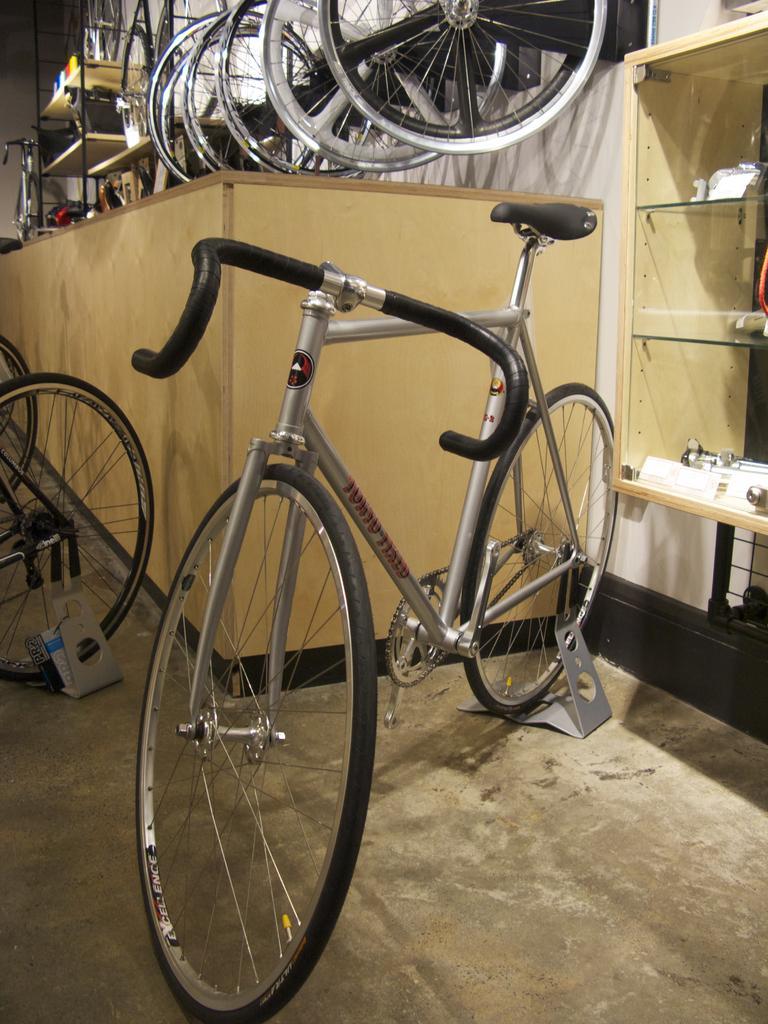Could you give a brief overview of what you see in this image? In front of the picture, we see the bicycle. Behind that, we see a table on which the bicycles are placed. On the right side, we see a rack. In the background, we see the bicycles and a rack. This picture might be clicked in the bicycle garage. 